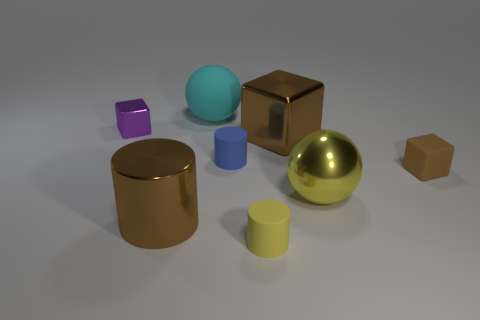What number of cylinders are either small green rubber objects or blue objects?
Keep it short and to the point. 1. What number of small purple objects are there?
Give a very brief answer. 1. How big is the sphere that is behind the small block behind the large cube?
Your response must be concise. Large. What number of other things are there of the same size as the cyan rubber ball?
Your response must be concise. 3. How many tiny purple metallic cubes are to the right of the yellow rubber thing?
Offer a terse response. 0. How big is the cyan rubber object?
Provide a succinct answer. Large. Is the material of the yellow object that is left of the big shiny block the same as the small cube in front of the purple block?
Offer a very short reply. Yes. Is there a big metal block of the same color as the large metallic cylinder?
Provide a short and direct response. Yes. There is a metallic block that is the same size as the shiny cylinder; what color is it?
Make the answer very short. Brown. Do the tiny thing to the right of the metal sphere and the large cube have the same color?
Your answer should be compact. Yes. 